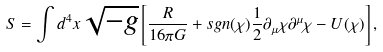<formula> <loc_0><loc_0><loc_500><loc_500>S = \int d ^ { 4 } x \sqrt { - g } \left [ \frac { R } { 1 6 \pi G } + s g n ( \chi ) \frac { 1 } { 2 } \partial _ { \mu } \chi \partial ^ { \mu } \chi - U ( \chi ) \right ] ,</formula> 